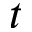Convert formula to latex. <formula><loc_0><loc_0><loc_500><loc_500>t</formula> 